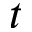Convert formula to latex. <formula><loc_0><loc_0><loc_500><loc_500>t</formula> 